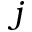Convert formula to latex. <formula><loc_0><loc_0><loc_500><loc_500>j</formula> 